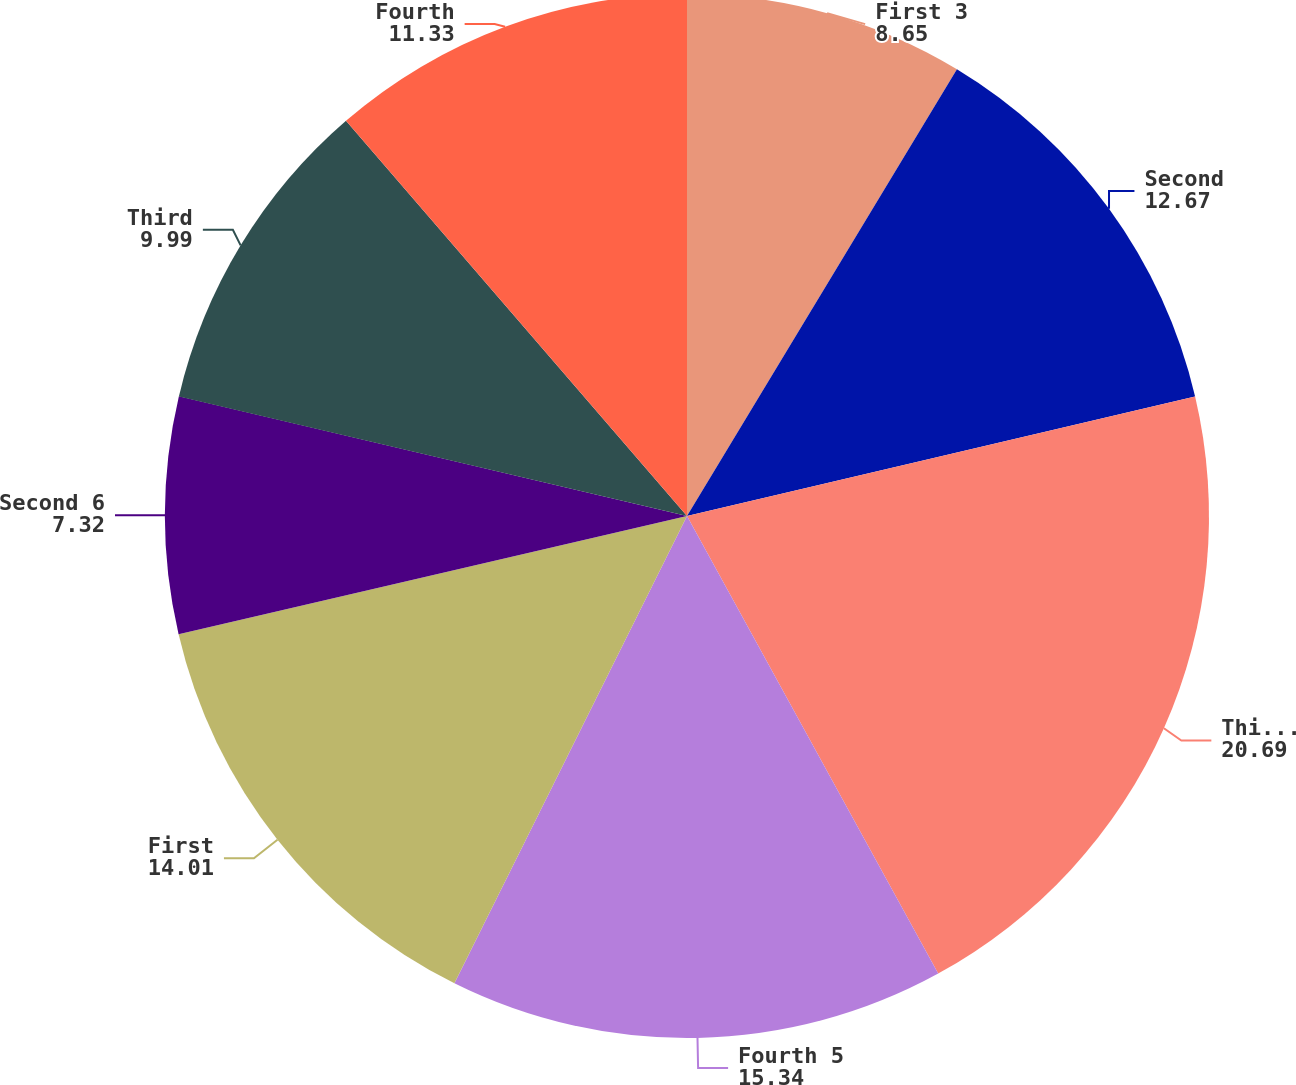Convert chart to OTSL. <chart><loc_0><loc_0><loc_500><loc_500><pie_chart><fcel>First 3<fcel>Second<fcel>Third 4<fcel>Fourth 5<fcel>First<fcel>Second 6<fcel>Third<fcel>Fourth<nl><fcel>8.65%<fcel>12.67%<fcel>20.69%<fcel>15.34%<fcel>14.01%<fcel>7.32%<fcel>9.99%<fcel>11.33%<nl></chart> 